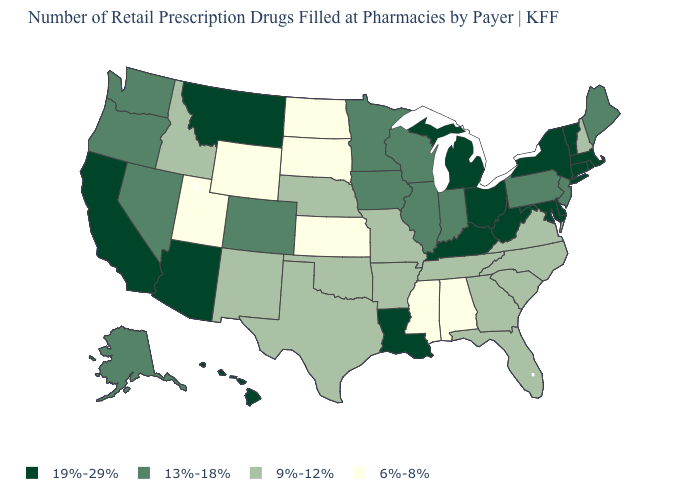What is the lowest value in the USA?
Short answer required. 6%-8%. Name the states that have a value in the range 6%-8%?
Write a very short answer. Alabama, Kansas, Mississippi, North Dakota, South Dakota, Utah, Wyoming. What is the lowest value in the USA?
Concise answer only. 6%-8%. What is the value of Vermont?
Keep it brief. 19%-29%. What is the value of Montana?
Keep it brief. 19%-29%. Is the legend a continuous bar?
Answer briefly. No. Which states have the lowest value in the MidWest?
Concise answer only. Kansas, North Dakota, South Dakota. Does the map have missing data?
Quick response, please. No. Does Tennessee have the highest value in the South?
Be succinct. No. What is the highest value in the USA?
Concise answer only. 19%-29%. Does North Carolina have the same value as Missouri?
Give a very brief answer. Yes. Name the states that have a value in the range 9%-12%?
Give a very brief answer. Arkansas, Florida, Georgia, Idaho, Missouri, Nebraska, New Hampshire, New Mexico, North Carolina, Oklahoma, South Carolina, Tennessee, Texas, Virginia. Name the states that have a value in the range 6%-8%?
Keep it brief. Alabama, Kansas, Mississippi, North Dakota, South Dakota, Utah, Wyoming. Does Pennsylvania have the highest value in the USA?
Short answer required. No. Which states have the highest value in the USA?
Short answer required. Arizona, California, Connecticut, Delaware, Hawaii, Kentucky, Louisiana, Maryland, Massachusetts, Michigan, Montana, New York, Ohio, Rhode Island, Vermont, West Virginia. 